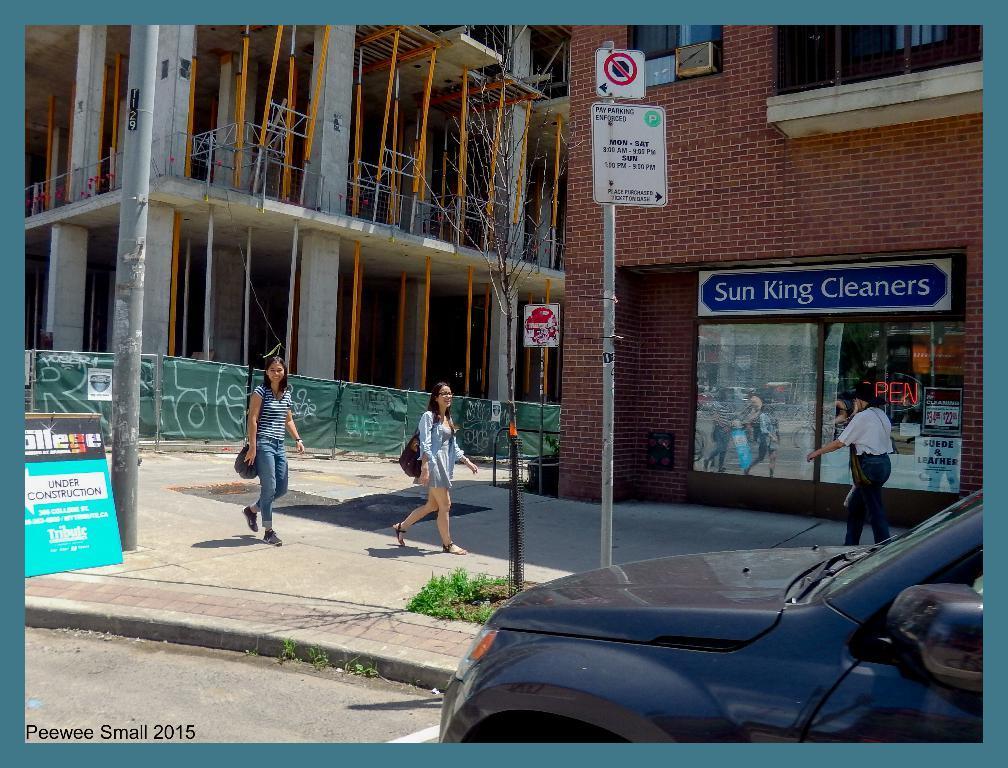Please provide a concise description of this image. In the center of the image there are buildings. We can see people walking. There is a sign board and we can see a pole. On the right there is a car. 